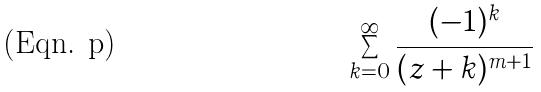<formula> <loc_0><loc_0><loc_500><loc_500>\sum _ { k = 0 } ^ { \infty } \frac { ( - 1 ) ^ { k } } { ( z + k ) ^ { m + 1 } }</formula> 